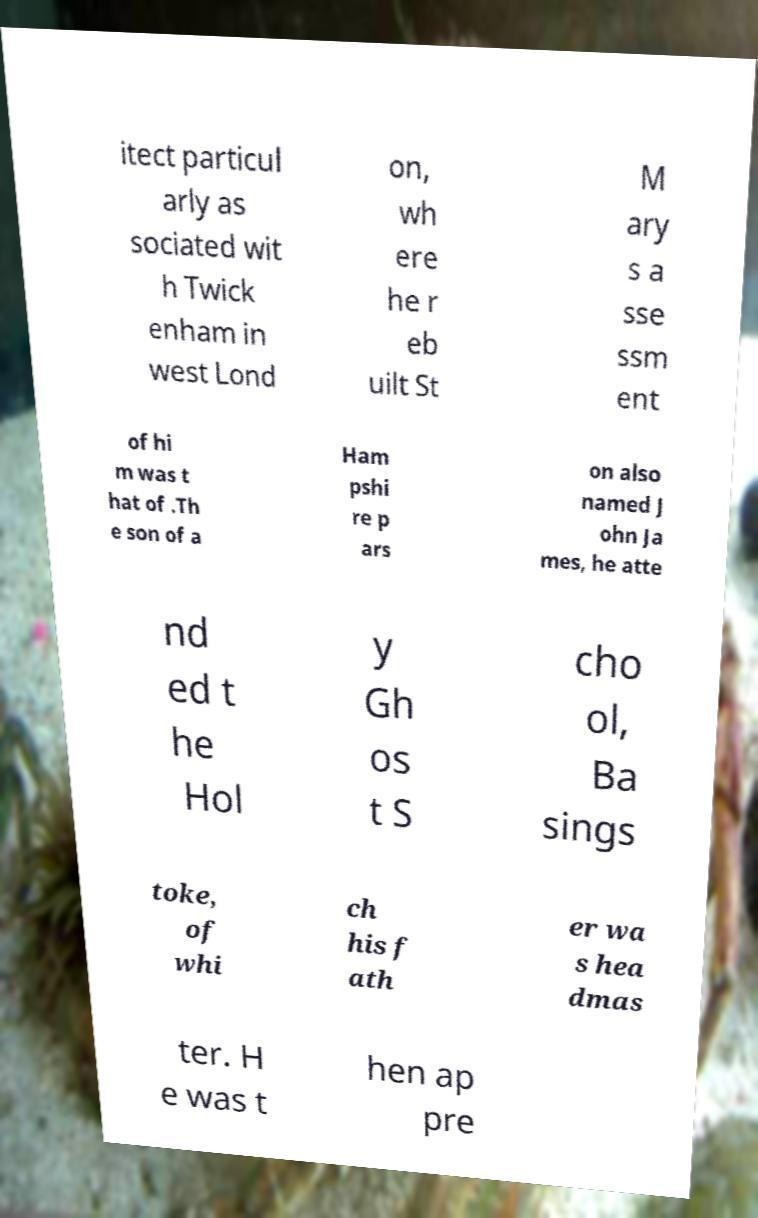Please read and relay the text visible in this image. What does it say? itect particul arly as sociated wit h Twick enham in west Lond on, wh ere he r eb uilt St M ary s a sse ssm ent of hi m was t hat of .Th e son of a Ham pshi re p ars on also named J ohn Ja mes, he atte nd ed t he Hol y Gh os t S cho ol, Ba sings toke, of whi ch his f ath er wa s hea dmas ter. H e was t hen ap pre 